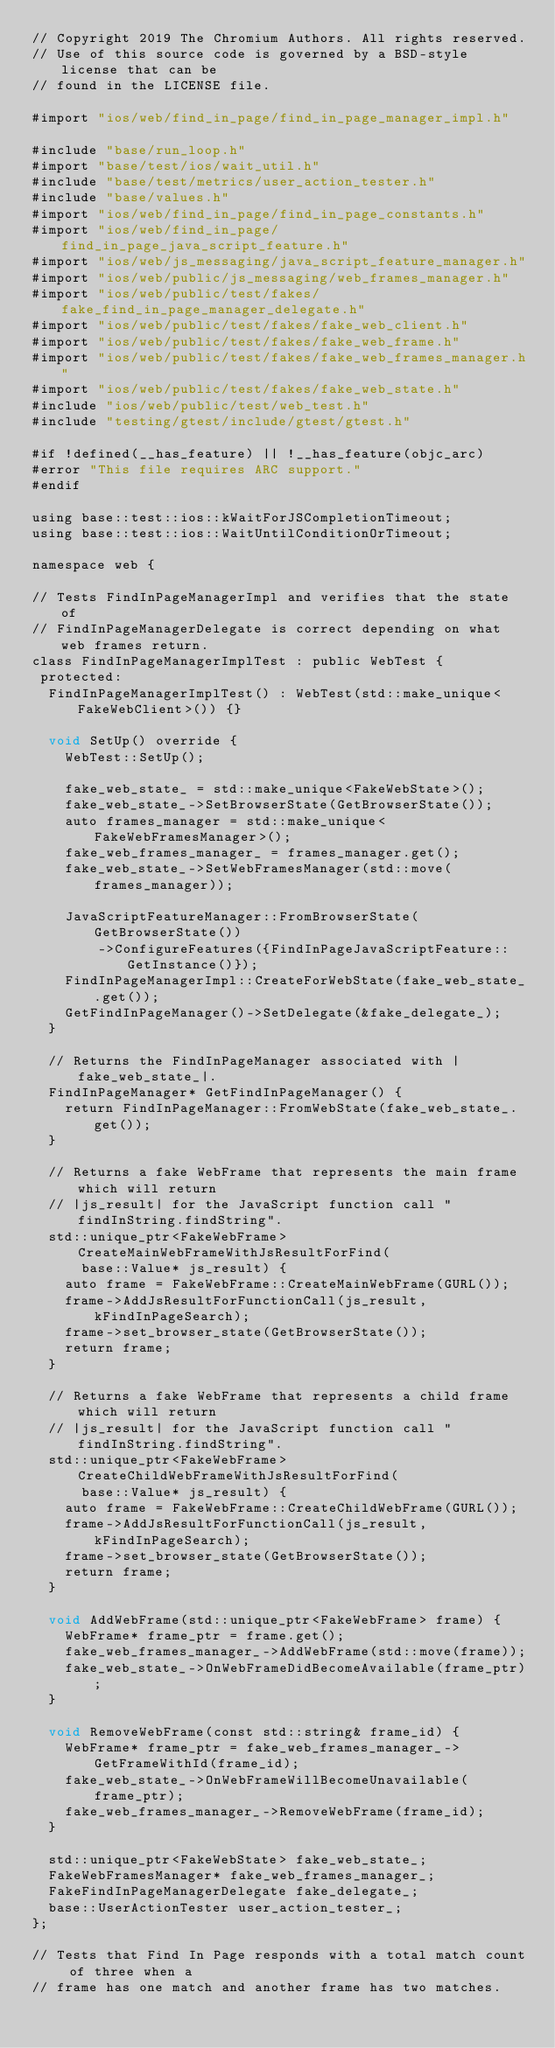Convert code to text. <code><loc_0><loc_0><loc_500><loc_500><_ObjectiveC_>// Copyright 2019 The Chromium Authors. All rights reserved.
// Use of this source code is governed by a BSD-style license that can be
// found in the LICENSE file.

#import "ios/web/find_in_page/find_in_page_manager_impl.h"

#include "base/run_loop.h"
#import "base/test/ios/wait_util.h"
#include "base/test/metrics/user_action_tester.h"
#include "base/values.h"
#import "ios/web/find_in_page/find_in_page_constants.h"
#import "ios/web/find_in_page/find_in_page_java_script_feature.h"
#import "ios/web/js_messaging/java_script_feature_manager.h"
#import "ios/web/public/js_messaging/web_frames_manager.h"
#import "ios/web/public/test/fakes/fake_find_in_page_manager_delegate.h"
#import "ios/web/public/test/fakes/fake_web_client.h"
#import "ios/web/public/test/fakes/fake_web_frame.h"
#import "ios/web/public/test/fakes/fake_web_frames_manager.h"
#import "ios/web/public/test/fakes/fake_web_state.h"
#include "ios/web/public/test/web_test.h"
#include "testing/gtest/include/gtest/gtest.h"

#if !defined(__has_feature) || !__has_feature(objc_arc)
#error "This file requires ARC support."
#endif

using base::test::ios::kWaitForJSCompletionTimeout;
using base::test::ios::WaitUntilConditionOrTimeout;

namespace web {

// Tests FindInPageManagerImpl and verifies that the state of
// FindInPageManagerDelegate is correct depending on what web frames return.
class FindInPageManagerImplTest : public WebTest {
 protected:
  FindInPageManagerImplTest() : WebTest(std::make_unique<FakeWebClient>()) {}

  void SetUp() override {
    WebTest::SetUp();

    fake_web_state_ = std::make_unique<FakeWebState>();
    fake_web_state_->SetBrowserState(GetBrowserState());
    auto frames_manager = std::make_unique<FakeWebFramesManager>();
    fake_web_frames_manager_ = frames_manager.get();
    fake_web_state_->SetWebFramesManager(std::move(frames_manager));

    JavaScriptFeatureManager::FromBrowserState(GetBrowserState())
        ->ConfigureFeatures({FindInPageJavaScriptFeature::GetInstance()});
    FindInPageManagerImpl::CreateForWebState(fake_web_state_.get());
    GetFindInPageManager()->SetDelegate(&fake_delegate_);
  }

  // Returns the FindInPageManager associated with |fake_web_state_|.
  FindInPageManager* GetFindInPageManager() {
    return FindInPageManager::FromWebState(fake_web_state_.get());
  }

  // Returns a fake WebFrame that represents the main frame which will return
  // |js_result| for the JavaScript function call "findInString.findString".
  std::unique_ptr<FakeWebFrame> CreateMainWebFrameWithJsResultForFind(
      base::Value* js_result) {
    auto frame = FakeWebFrame::CreateMainWebFrame(GURL());
    frame->AddJsResultForFunctionCall(js_result, kFindInPageSearch);
    frame->set_browser_state(GetBrowserState());
    return frame;
  }

  // Returns a fake WebFrame that represents a child frame which will return
  // |js_result| for the JavaScript function call "findInString.findString".
  std::unique_ptr<FakeWebFrame> CreateChildWebFrameWithJsResultForFind(
      base::Value* js_result) {
    auto frame = FakeWebFrame::CreateChildWebFrame(GURL());
    frame->AddJsResultForFunctionCall(js_result, kFindInPageSearch);
    frame->set_browser_state(GetBrowserState());
    return frame;
  }

  void AddWebFrame(std::unique_ptr<FakeWebFrame> frame) {
    WebFrame* frame_ptr = frame.get();
    fake_web_frames_manager_->AddWebFrame(std::move(frame));
    fake_web_state_->OnWebFrameDidBecomeAvailable(frame_ptr);
  }

  void RemoveWebFrame(const std::string& frame_id) {
    WebFrame* frame_ptr = fake_web_frames_manager_->GetFrameWithId(frame_id);
    fake_web_state_->OnWebFrameWillBecomeUnavailable(frame_ptr);
    fake_web_frames_manager_->RemoveWebFrame(frame_id);
  }

  std::unique_ptr<FakeWebState> fake_web_state_;
  FakeWebFramesManager* fake_web_frames_manager_;
  FakeFindInPageManagerDelegate fake_delegate_;
  base::UserActionTester user_action_tester_;
};

// Tests that Find In Page responds with a total match count of three when a
// frame has one match and another frame has two matches.</code> 